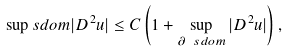Convert formula to latex. <formula><loc_0><loc_0><loc_500><loc_500>\sup _ { \ } s d o m | D ^ { 2 } u | \leq C \left ( 1 + \sup _ { \partial \ s d o m } | D ^ { 2 } u | \right ) ,</formula> 